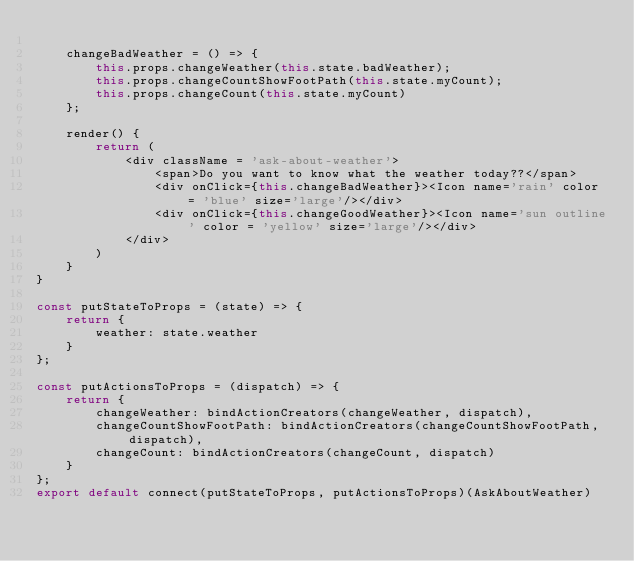Convert code to text. <code><loc_0><loc_0><loc_500><loc_500><_JavaScript_>
    changeBadWeather = () => {
        this.props.changeWeather(this.state.badWeather);
        this.props.changeCountShowFootPath(this.state.myCount);
        this.props.changeCount(this.state.myCount)
    };

    render() {
        return (
            <div className = 'ask-about-weather'>
                <span>Do you want to know what the weather today??</span>
                <div onClick={this.changeBadWeather}><Icon name='rain' color = 'blue' size='large'/></div>
                <div onClick={this.changeGoodWeather}><Icon name='sun outline' color = 'yellow' size='large'/></div>
            </div>
        )
    }
}

const putStateToProps = (state) => {
    return {
        weather: state.weather
    }
};

const putActionsToProps = (dispatch) => {
    return {
        changeWeather: bindActionCreators(changeWeather, dispatch),
        changeCountShowFootPath: bindActionCreators(changeCountShowFootPath, dispatch),
        changeCount: bindActionCreators(changeCount, dispatch)
    }
};
export default connect(putStateToProps, putActionsToProps)(AskAboutWeather)
</code> 